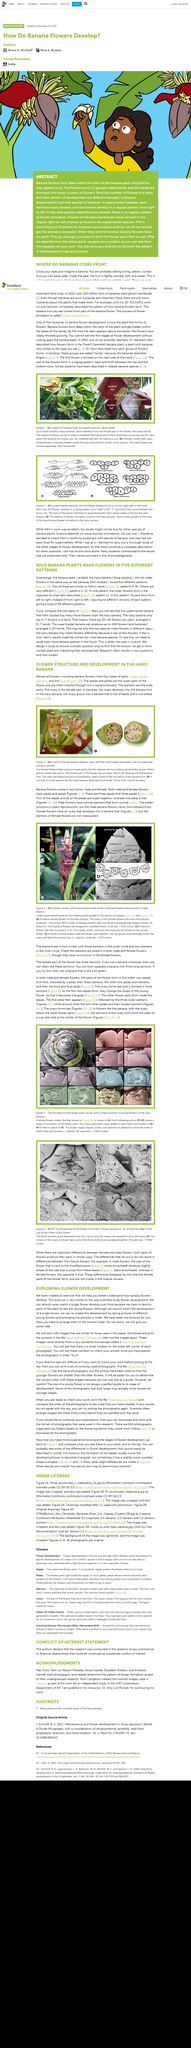Point out several critical features in this image. Hairy bananas are not edible. It is not possible for stamens found in female flowers to produce good quality pollen. In the banana plant, the ovary develops into the banana fruit. Wild banana plants produce flowers in five distinct patterns. The image in Figure 5L shows that all of the stamen are labeled. 